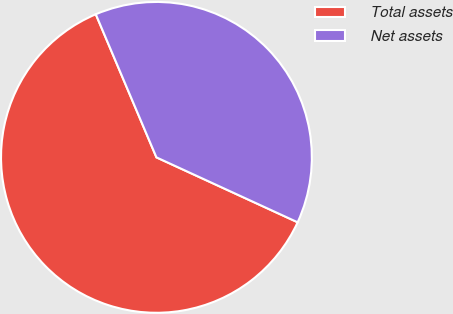Convert chart to OTSL. <chart><loc_0><loc_0><loc_500><loc_500><pie_chart><fcel>Total assets<fcel>Net assets<nl><fcel>61.76%<fcel>38.24%<nl></chart> 